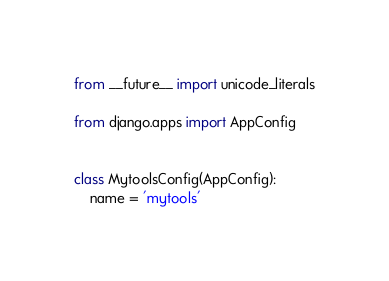Convert code to text. <code><loc_0><loc_0><loc_500><loc_500><_Python_>from __future__ import unicode_literals

from django.apps import AppConfig


class MytoolsConfig(AppConfig):
    name = 'mytools'
</code> 